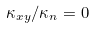Convert formula to latex. <formula><loc_0><loc_0><loc_500><loc_500>\kappa _ { x y } / \kappa _ { n } = 0</formula> 